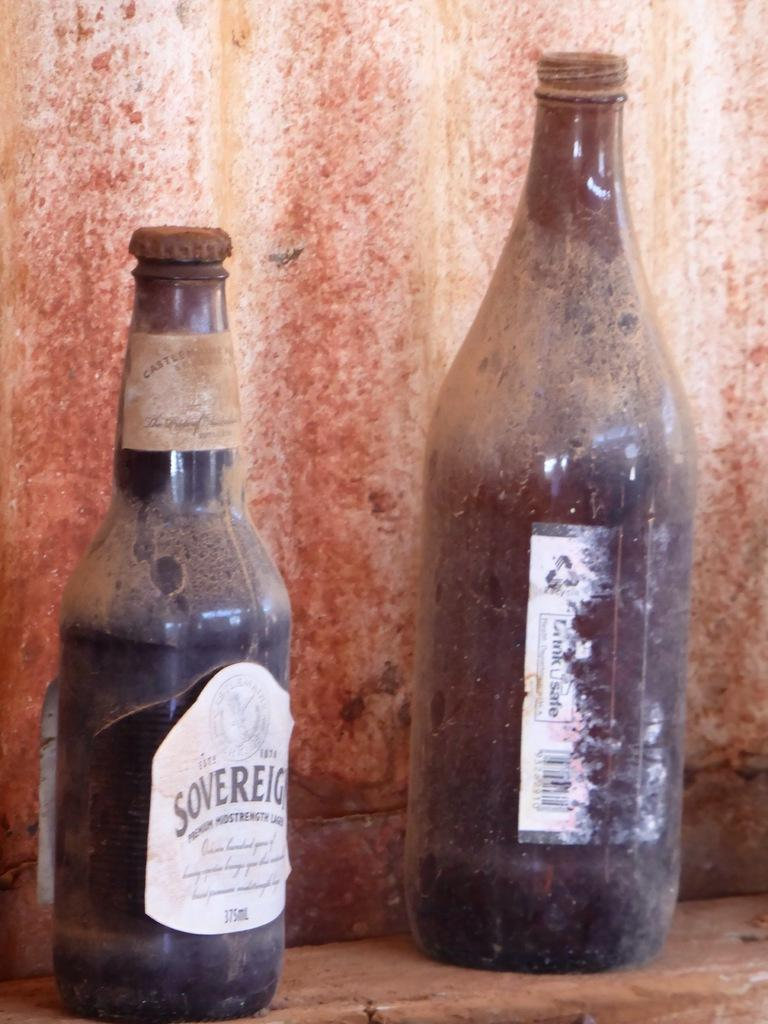<image>
Offer a succinct explanation of the picture presented. Brown bottle of Sovereign beer next to another dirty bottle. 